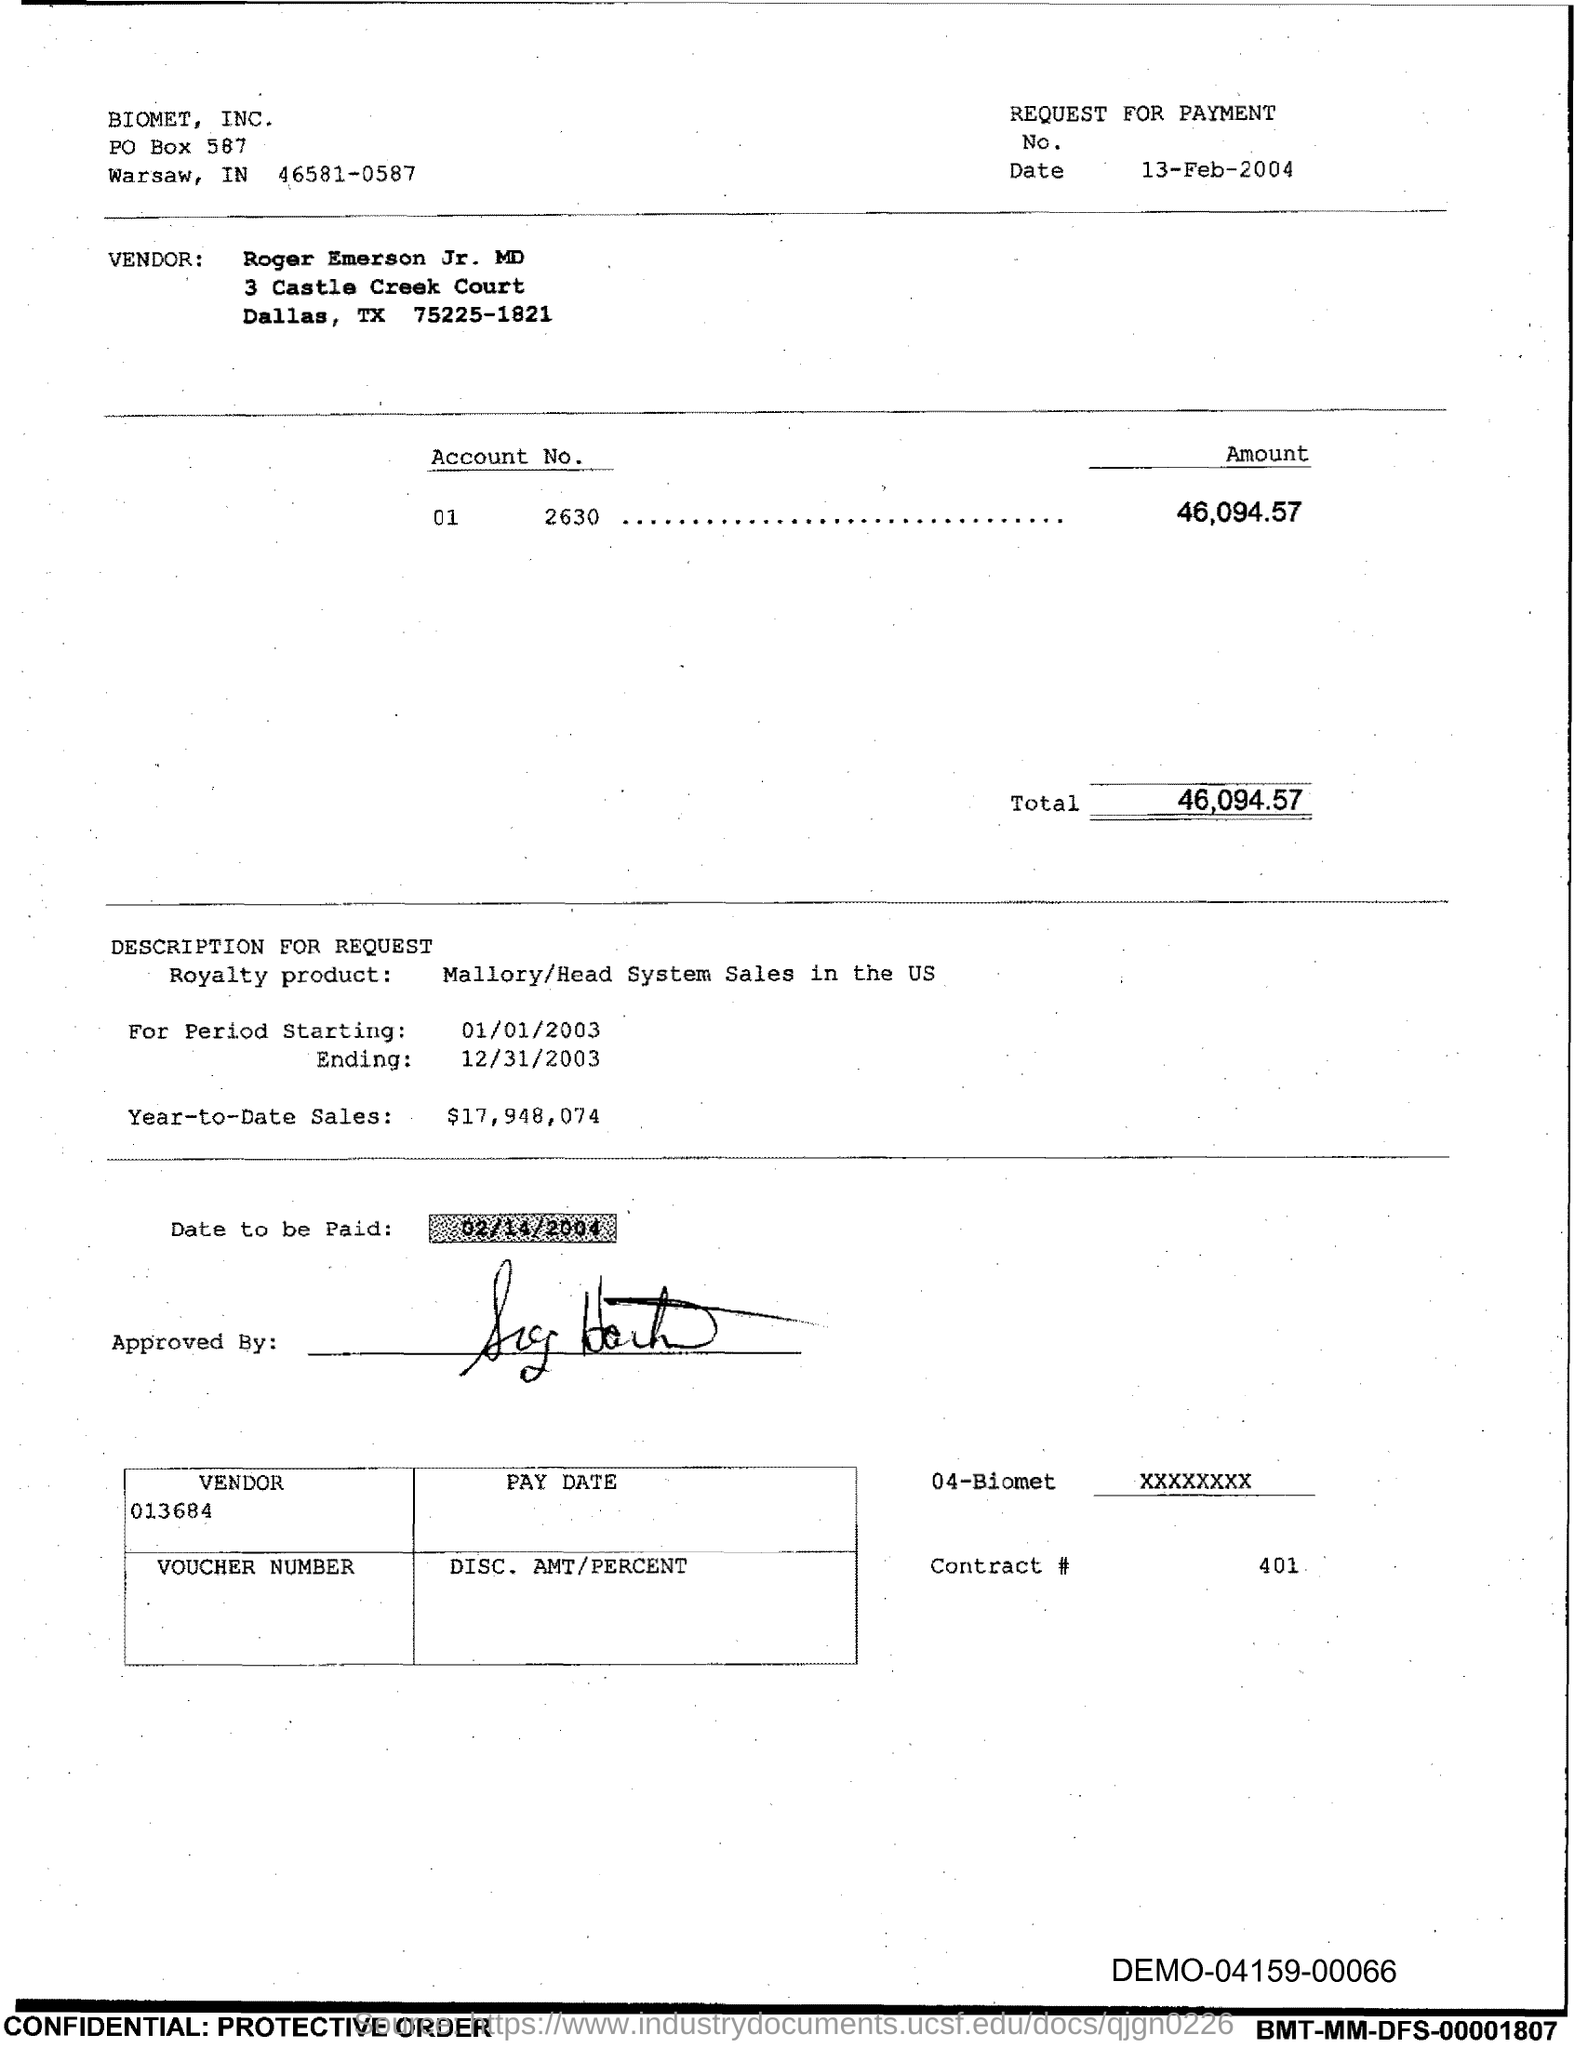What is the date to be paid?
Make the answer very short. 02/14/2004. What is Contract #?
Keep it short and to the point. 401. What is the Total?
Keep it short and to the point. 46,094.57. What is the PO Box Number mentioned in the document?
Provide a succinct answer. 587. 